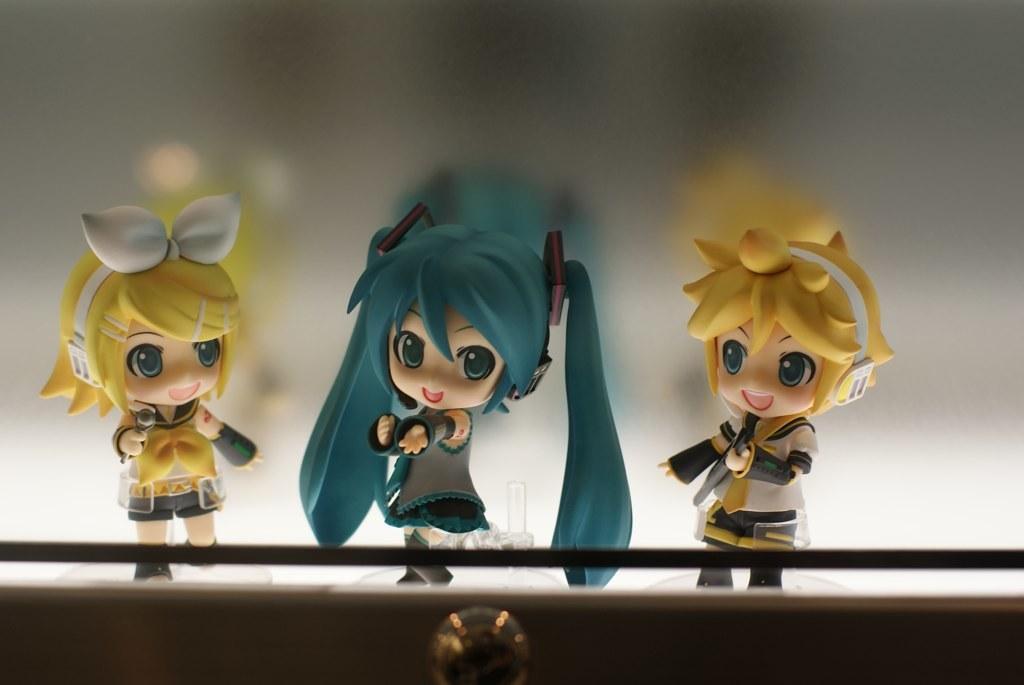How would you summarize this image in a sentence or two? In the center of the picture there are three dolls, behind them there is a white surface. At the bottom it is looking like a locker. 